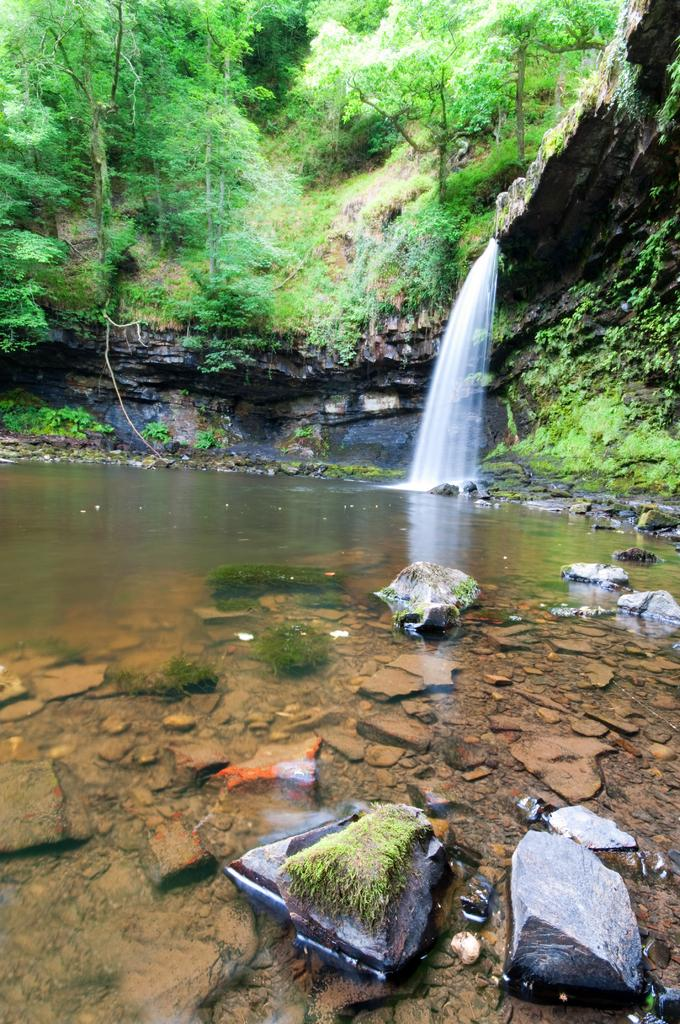What is the main feature in the middle of the image? There is a waterfall in the middle of the image. What can be seen at the bottom of the waterfall? Stones are present in the water at the bottom of the waterfall. What type of vegetation is visible at the top of the waterfall? There are trees on the hill at the top of the waterfall. What type of grain is being discussed by the committee in the image? There is no committee or grain present in the image; it features a waterfall with stones and trees. What type of pest can be seen crawling on the waterfall in the image? There are no pests visible in the image; it features a waterfall with stones and trees. 